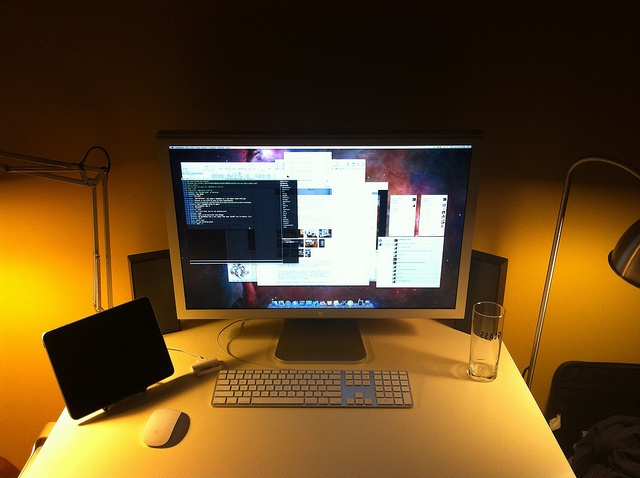Describe the objects in this image and their specific colors. I can see tv in black, ivory, navy, and maroon tones, tv in black, orange, maroon, and gold tones, laptop in black and maroon tones, keyboard in black, gray, maroon, and olive tones, and cup in black, orange, maroon, and olive tones in this image. 